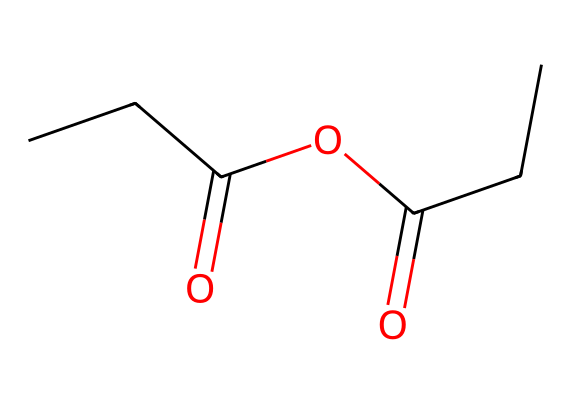What is the total number of carbon atoms in propionic anhydride? In the given SMILES representation, there are two carbon atoms in the propionic acid part (CCC), and two more in the anhydride linkage (C(=O) and another C(=O)). Counting these, there are a total of four carbon atoms.
Answer: four How many oxygen atoms are present in the structure of propionic anhydride? Looking at the structure from the SMILES representation, the molecule contains two double-bonded oxygen atoms in the anhydride formation and one more attached to the carbon chain, totaling three oxygen atoms in the structure.
Answer: three What is the degree of unsaturation in propionic anhydride? The formula for calculating the degree of unsaturation is (2C + 2 + N - H - X)/2. Counting the atoms: C = 4, H = 6, O = 3 (no N or X). Plugging these into the formula yields (2(4) + 2 - 6)/2 = 2, indicating two degrees of unsaturation, which is indicative of the double bonds present in the carbonyl groups.
Answer: two What types of functional groups are identified in propionic anhydride? The structure exhibits two types of functional groups: the anhydride functional group (RCO-O-COR) indicated by the two carbonyl (C=O) groups and an ester bond (RCOOR), which is characterized by the presence of oxygen between two carbonyl groups.
Answer: anhydride and ester Is propionic anhydride classified as a saturated or unsaturated compound? The presence of carbonyl double bonds (C=O) in the structure indicates the presence of unsaturation, while the alkyl chain is saturated (single bonds). Since there are double bonds, the compound is classified as unsaturated.
Answer: unsaturated 